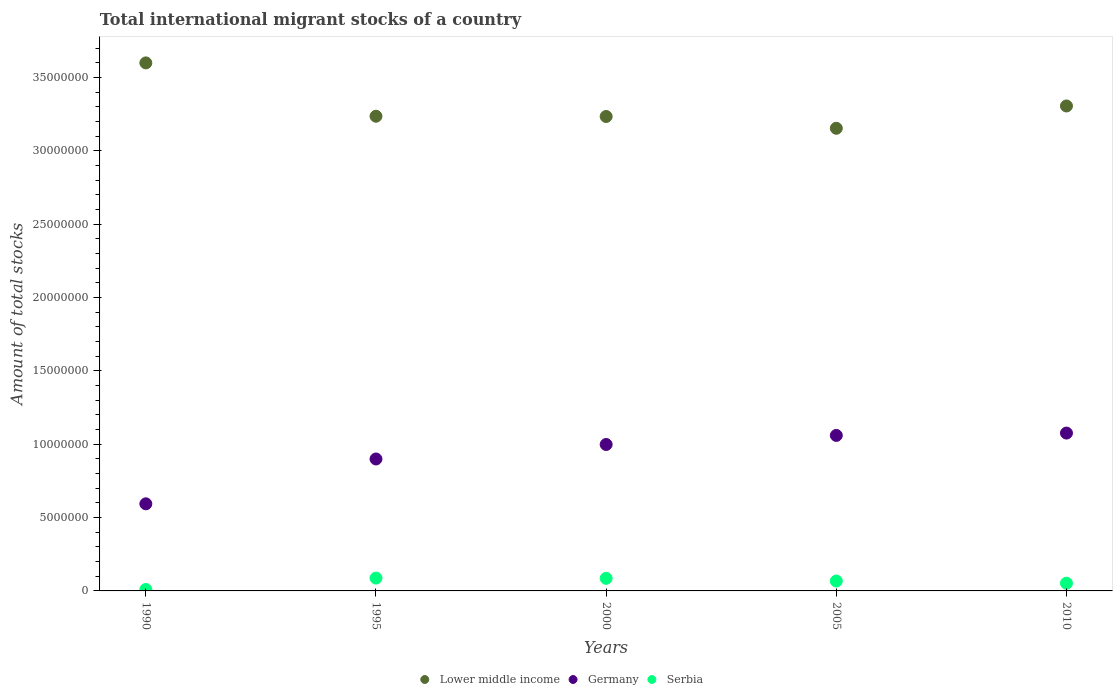Is the number of dotlines equal to the number of legend labels?
Give a very brief answer. Yes. What is the amount of total stocks in in Serbia in 2010?
Your response must be concise. 5.25e+05. Across all years, what is the maximum amount of total stocks in in Germany?
Keep it short and to the point. 1.08e+07. Across all years, what is the minimum amount of total stocks in in Lower middle income?
Offer a very short reply. 3.15e+07. In which year was the amount of total stocks in in Germany minimum?
Provide a succinct answer. 1990. What is the total amount of total stocks in in Germany in the graph?
Make the answer very short. 4.63e+07. What is the difference between the amount of total stocks in in Germany in 1990 and that in 2010?
Offer a very short reply. -4.82e+06. What is the difference between the amount of total stocks in in Germany in 1995 and the amount of total stocks in in Serbia in 2010?
Provide a succinct answer. 8.47e+06. What is the average amount of total stocks in in Lower middle income per year?
Offer a terse response. 3.31e+07. In the year 2000, what is the difference between the amount of total stocks in in Lower middle income and amount of total stocks in in Germany?
Provide a succinct answer. 2.24e+07. What is the ratio of the amount of total stocks in in Lower middle income in 2000 to that in 2005?
Provide a short and direct response. 1.03. Is the amount of total stocks in in Serbia in 1995 less than that in 2010?
Ensure brevity in your answer.  No. What is the difference between the highest and the second highest amount of total stocks in in Serbia?
Your answer should be very brief. 1.70e+04. What is the difference between the highest and the lowest amount of total stocks in in Lower middle income?
Ensure brevity in your answer.  4.46e+06. Is the sum of the amount of total stocks in in Germany in 2000 and 2010 greater than the maximum amount of total stocks in in Serbia across all years?
Provide a succinct answer. Yes. How many dotlines are there?
Your answer should be very brief. 3. How many years are there in the graph?
Your answer should be very brief. 5. What is the difference between two consecutive major ticks on the Y-axis?
Ensure brevity in your answer.  5.00e+06. Are the values on the major ticks of Y-axis written in scientific E-notation?
Offer a terse response. No. Does the graph contain any zero values?
Your answer should be compact. No. Does the graph contain grids?
Make the answer very short. No. How are the legend labels stacked?
Keep it short and to the point. Horizontal. What is the title of the graph?
Offer a terse response. Total international migrant stocks of a country. Does "Peru" appear as one of the legend labels in the graph?
Make the answer very short. No. What is the label or title of the Y-axis?
Provide a short and direct response. Amount of total stocks. What is the Amount of total stocks of Lower middle income in 1990?
Keep it short and to the point. 3.60e+07. What is the Amount of total stocks in Germany in 1990?
Ensure brevity in your answer.  5.94e+06. What is the Amount of total stocks in Serbia in 1990?
Ensure brevity in your answer.  9.93e+04. What is the Amount of total stocks of Lower middle income in 1995?
Provide a succinct answer. 3.24e+07. What is the Amount of total stocks of Germany in 1995?
Offer a very short reply. 8.99e+06. What is the Amount of total stocks of Serbia in 1995?
Offer a terse response. 8.74e+05. What is the Amount of total stocks in Lower middle income in 2000?
Your response must be concise. 3.23e+07. What is the Amount of total stocks of Germany in 2000?
Provide a short and direct response. 9.98e+06. What is the Amount of total stocks in Serbia in 2000?
Provide a short and direct response. 8.57e+05. What is the Amount of total stocks of Lower middle income in 2005?
Ensure brevity in your answer.  3.15e+07. What is the Amount of total stocks of Germany in 2005?
Provide a succinct answer. 1.06e+07. What is the Amount of total stocks in Serbia in 2005?
Give a very brief answer. 6.75e+05. What is the Amount of total stocks in Lower middle income in 2010?
Provide a short and direct response. 3.31e+07. What is the Amount of total stocks of Germany in 2010?
Provide a succinct answer. 1.08e+07. What is the Amount of total stocks in Serbia in 2010?
Give a very brief answer. 5.25e+05. Across all years, what is the maximum Amount of total stocks of Lower middle income?
Your answer should be very brief. 3.60e+07. Across all years, what is the maximum Amount of total stocks of Germany?
Offer a terse response. 1.08e+07. Across all years, what is the maximum Amount of total stocks in Serbia?
Provide a succinct answer. 8.74e+05. Across all years, what is the minimum Amount of total stocks in Lower middle income?
Your answer should be compact. 3.15e+07. Across all years, what is the minimum Amount of total stocks in Germany?
Provide a succinct answer. 5.94e+06. Across all years, what is the minimum Amount of total stocks in Serbia?
Your answer should be very brief. 9.93e+04. What is the total Amount of total stocks of Lower middle income in the graph?
Make the answer very short. 1.65e+08. What is the total Amount of total stocks in Germany in the graph?
Keep it short and to the point. 4.63e+07. What is the total Amount of total stocks of Serbia in the graph?
Make the answer very short. 3.03e+06. What is the difference between the Amount of total stocks of Lower middle income in 1990 and that in 1995?
Provide a succinct answer. 3.63e+06. What is the difference between the Amount of total stocks in Germany in 1990 and that in 1995?
Make the answer very short. -3.06e+06. What is the difference between the Amount of total stocks in Serbia in 1990 and that in 1995?
Ensure brevity in your answer.  -7.75e+05. What is the difference between the Amount of total stocks of Lower middle income in 1990 and that in 2000?
Give a very brief answer. 3.65e+06. What is the difference between the Amount of total stocks in Germany in 1990 and that in 2000?
Provide a short and direct response. -4.04e+06. What is the difference between the Amount of total stocks in Serbia in 1990 and that in 2000?
Make the answer very short. -7.57e+05. What is the difference between the Amount of total stocks in Lower middle income in 1990 and that in 2005?
Provide a succinct answer. 4.46e+06. What is the difference between the Amount of total stocks in Germany in 1990 and that in 2005?
Your answer should be very brief. -4.66e+06. What is the difference between the Amount of total stocks in Serbia in 1990 and that in 2005?
Provide a succinct answer. -5.75e+05. What is the difference between the Amount of total stocks in Lower middle income in 1990 and that in 2010?
Your answer should be compact. 2.94e+06. What is the difference between the Amount of total stocks in Germany in 1990 and that in 2010?
Offer a very short reply. -4.82e+06. What is the difference between the Amount of total stocks in Serbia in 1990 and that in 2010?
Your response must be concise. -4.26e+05. What is the difference between the Amount of total stocks of Lower middle income in 1995 and that in 2000?
Offer a terse response. 1.76e+04. What is the difference between the Amount of total stocks of Germany in 1995 and that in 2000?
Provide a short and direct response. -9.89e+05. What is the difference between the Amount of total stocks in Serbia in 1995 and that in 2000?
Your answer should be very brief. 1.70e+04. What is the difference between the Amount of total stocks of Lower middle income in 1995 and that in 2005?
Your answer should be very brief. 8.21e+05. What is the difference between the Amount of total stocks of Germany in 1995 and that in 2005?
Provide a short and direct response. -1.61e+06. What is the difference between the Amount of total stocks in Serbia in 1995 and that in 2005?
Your answer should be very brief. 1.99e+05. What is the difference between the Amount of total stocks in Lower middle income in 1995 and that in 2010?
Your answer should be very brief. -6.99e+05. What is the difference between the Amount of total stocks of Germany in 1995 and that in 2010?
Keep it short and to the point. -1.77e+06. What is the difference between the Amount of total stocks of Serbia in 1995 and that in 2010?
Provide a short and direct response. 3.48e+05. What is the difference between the Amount of total stocks in Lower middle income in 2000 and that in 2005?
Give a very brief answer. 8.03e+05. What is the difference between the Amount of total stocks in Germany in 2000 and that in 2005?
Keep it short and to the point. -6.17e+05. What is the difference between the Amount of total stocks of Serbia in 2000 and that in 2005?
Provide a succinct answer. 1.82e+05. What is the difference between the Amount of total stocks of Lower middle income in 2000 and that in 2010?
Offer a terse response. -7.16e+05. What is the difference between the Amount of total stocks in Germany in 2000 and that in 2010?
Offer a terse response. -7.77e+05. What is the difference between the Amount of total stocks of Serbia in 2000 and that in 2010?
Make the answer very short. 3.31e+05. What is the difference between the Amount of total stocks of Lower middle income in 2005 and that in 2010?
Provide a succinct answer. -1.52e+06. What is the difference between the Amount of total stocks in Germany in 2005 and that in 2010?
Ensure brevity in your answer.  -1.60e+05. What is the difference between the Amount of total stocks of Serbia in 2005 and that in 2010?
Make the answer very short. 1.49e+05. What is the difference between the Amount of total stocks in Lower middle income in 1990 and the Amount of total stocks in Germany in 1995?
Keep it short and to the point. 2.70e+07. What is the difference between the Amount of total stocks in Lower middle income in 1990 and the Amount of total stocks in Serbia in 1995?
Keep it short and to the point. 3.51e+07. What is the difference between the Amount of total stocks of Germany in 1990 and the Amount of total stocks of Serbia in 1995?
Make the answer very short. 5.06e+06. What is the difference between the Amount of total stocks in Lower middle income in 1990 and the Amount of total stocks in Germany in 2000?
Offer a very short reply. 2.60e+07. What is the difference between the Amount of total stocks in Lower middle income in 1990 and the Amount of total stocks in Serbia in 2000?
Your response must be concise. 3.51e+07. What is the difference between the Amount of total stocks in Germany in 1990 and the Amount of total stocks in Serbia in 2000?
Your answer should be very brief. 5.08e+06. What is the difference between the Amount of total stocks in Lower middle income in 1990 and the Amount of total stocks in Germany in 2005?
Offer a terse response. 2.54e+07. What is the difference between the Amount of total stocks of Lower middle income in 1990 and the Amount of total stocks of Serbia in 2005?
Your answer should be compact. 3.53e+07. What is the difference between the Amount of total stocks in Germany in 1990 and the Amount of total stocks in Serbia in 2005?
Make the answer very short. 5.26e+06. What is the difference between the Amount of total stocks of Lower middle income in 1990 and the Amount of total stocks of Germany in 2010?
Make the answer very short. 2.52e+07. What is the difference between the Amount of total stocks in Lower middle income in 1990 and the Amount of total stocks in Serbia in 2010?
Your response must be concise. 3.55e+07. What is the difference between the Amount of total stocks in Germany in 1990 and the Amount of total stocks in Serbia in 2010?
Provide a short and direct response. 5.41e+06. What is the difference between the Amount of total stocks of Lower middle income in 1995 and the Amount of total stocks of Germany in 2000?
Offer a very short reply. 2.24e+07. What is the difference between the Amount of total stocks of Lower middle income in 1995 and the Amount of total stocks of Serbia in 2000?
Give a very brief answer. 3.15e+07. What is the difference between the Amount of total stocks in Germany in 1995 and the Amount of total stocks in Serbia in 2000?
Provide a short and direct response. 8.14e+06. What is the difference between the Amount of total stocks of Lower middle income in 1995 and the Amount of total stocks of Germany in 2005?
Your answer should be compact. 2.18e+07. What is the difference between the Amount of total stocks of Lower middle income in 1995 and the Amount of total stocks of Serbia in 2005?
Your answer should be compact. 3.17e+07. What is the difference between the Amount of total stocks of Germany in 1995 and the Amount of total stocks of Serbia in 2005?
Your answer should be very brief. 8.32e+06. What is the difference between the Amount of total stocks in Lower middle income in 1995 and the Amount of total stocks in Germany in 2010?
Your answer should be very brief. 2.16e+07. What is the difference between the Amount of total stocks of Lower middle income in 1995 and the Amount of total stocks of Serbia in 2010?
Give a very brief answer. 3.18e+07. What is the difference between the Amount of total stocks in Germany in 1995 and the Amount of total stocks in Serbia in 2010?
Give a very brief answer. 8.47e+06. What is the difference between the Amount of total stocks in Lower middle income in 2000 and the Amount of total stocks in Germany in 2005?
Ensure brevity in your answer.  2.17e+07. What is the difference between the Amount of total stocks in Lower middle income in 2000 and the Amount of total stocks in Serbia in 2005?
Your answer should be compact. 3.17e+07. What is the difference between the Amount of total stocks of Germany in 2000 and the Amount of total stocks of Serbia in 2005?
Offer a terse response. 9.31e+06. What is the difference between the Amount of total stocks of Lower middle income in 2000 and the Amount of total stocks of Germany in 2010?
Make the answer very short. 2.16e+07. What is the difference between the Amount of total stocks in Lower middle income in 2000 and the Amount of total stocks in Serbia in 2010?
Ensure brevity in your answer.  3.18e+07. What is the difference between the Amount of total stocks of Germany in 2000 and the Amount of total stocks of Serbia in 2010?
Your answer should be very brief. 9.46e+06. What is the difference between the Amount of total stocks in Lower middle income in 2005 and the Amount of total stocks in Germany in 2010?
Keep it short and to the point. 2.08e+07. What is the difference between the Amount of total stocks of Lower middle income in 2005 and the Amount of total stocks of Serbia in 2010?
Your response must be concise. 3.10e+07. What is the difference between the Amount of total stocks in Germany in 2005 and the Amount of total stocks in Serbia in 2010?
Ensure brevity in your answer.  1.01e+07. What is the average Amount of total stocks of Lower middle income per year?
Offer a very short reply. 3.31e+07. What is the average Amount of total stocks in Germany per year?
Provide a short and direct response. 9.25e+06. What is the average Amount of total stocks in Serbia per year?
Offer a terse response. 6.06e+05. In the year 1990, what is the difference between the Amount of total stocks of Lower middle income and Amount of total stocks of Germany?
Give a very brief answer. 3.01e+07. In the year 1990, what is the difference between the Amount of total stocks of Lower middle income and Amount of total stocks of Serbia?
Give a very brief answer. 3.59e+07. In the year 1990, what is the difference between the Amount of total stocks of Germany and Amount of total stocks of Serbia?
Provide a short and direct response. 5.84e+06. In the year 1995, what is the difference between the Amount of total stocks in Lower middle income and Amount of total stocks in Germany?
Provide a short and direct response. 2.34e+07. In the year 1995, what is the difference between the Amount of total stocks of Lower middle income and Amount of total stocks of Serbia?
Keep it short and to the point. 3.15e+07. In the year 1995, what is the difference between the Amount of total stocks of Germany and Amount of total stocks of Serbia?
Your response must be concise. 8.12e+06. In the year 2000, what is the difference between the Amount of total stocks in Lower middle income and Amount of total stocks in Germany?
Give a very brief answer. 2.24e+07. In the year 2000, what is the difference between the Amount of total stocks in Lower middle income and Amount of total stocks in Serbia?
Provide a short and direct response. 3.15e+07. In the year 2000, what is the difference between the Amount of total stocks of Germany and Amount of total stocks of Serbia?
Provide a succinct answer. 9.12e+06. In the year 2005, what is the difference between the Amount of total stocks of Lower middle income and Amount of total stocks of Germany?
Ensure brevity in your answer.  2.09e+07. In the year 2005, what is the difference between the Amount of total stocks in Lower middle income and Amount of total stocks in Serbia?
Provide a succinct answer. 3.09e+07. In the year 2005, what is the difference between the Amount of total stocks in Germany and Amount of total stocks in Serbia?
Offer a terse response. 9.92e+06. In the year 2010, what is the difference between the Amount of total stocks in Lower middle income and Amount of total stocks in Germany?
Your answer should be compact. 2.23e+07. In the year 2010, what is the difference between the Amount of total stocks of Lower middle income and Amount of total stocks of Serbia?
Your response must be concise. 3.25e+07. In the year 2010, what is the difference between the Amount of total stocks in Germany and Amount of total stocks in Serbia?
Give a very brief answer. 1.02e+07. What is the ratio of the Amount of total stocks in Lower middle income in 1990 to that in 1995?
Give a very brief answer. 1.11. What is the ratio of the Amount of total stocks in Germany in 1990 to that in 1995?
Provide a short and direct response. 0.66. What is the ratio of the Amount of total stocks in Serbia in 1990 to that in 1995?
Provide a short and direct response. 0.11. What is the ratio of the Amount of total stocks of Lower middle income in 1990 to that in 2000?
Ensure brevity in your answer.  1.11. What is the ratio of the Amount of total stocks in Germany in 1990 to that in 2000?
Make the answer very short. 0.59. What is the ratio of the Amount of total stocks of Serbia in 1990 to that in 2000?
Your response must be concise. 0.12. What is the ratio of the Amount of total stocks of Lower middle income in 1990 to that in 2005?
Your response must be concise. 1.14. What is the ratio of the Amount of total stocks in Germany in 1990 to that in 2005?
Your answer should be very brief. 0.56. What is the ratio of the Amount of total stocks in Serbia in 1990 to that in 2005?
Keep it short and to the point. 0.15. What is the ratio of the Amount of total stocks of Lower middle income in 1990 to that in 2010?
Your answer should be very brief. 1.09. What is the ratio of the Amount of total stocks of Germany in 1990 to that in 2010?
Keep it short and to the point. 0.55. What is the ratio of the Amount of total stocks in Serbia in 1990 to that in 2010?
Your response must be concise. 0.19. What is the ratio of the Amount of total stocks in Germany in 1995 to that in 2000?
Your answer should be compact. 0.9. What is the ratio of the Amount of total stocks of Serbia in 1995 to that in 2000?
Provide a succinct answer. 1.02. What is the ratio of the Amount of total stocks in Germany in 1995 to that in 2005?
Keep it short and to the point. 0.85. What is the ratio of the Amount of total stocks of Serbia in 1995 to that in 2005?
Your response must be concise. 1.3. What is the ratio of the Amount of total stocks of Lower middle income in 1995 to that in 2010?
Ensure brevity in your answer.  0.98. What is the ratio of the Amount of total stocks of Germany in 1995 to that in 2010?
Ensure brevity in your answer.  0.84. What is the ratio of the Amount of total stocks of Serbia in 1995 to that in 2010?
Provide a succinct answer. 1.66. What is the ratio of the Amount of total stocks in Lower middle income in 2000 to that in 2005?
Keep it short and to the point. 1.03. What is the ratio of the Amount of total stocks of Germany in 2000 to that in 2005?
Make the answer very short. 0.94. What is the ratio of the Amount of total stocks of Serbia in 2000 to that in 2005?
Keep it short and to the point. 1.27. What is the ratio of the Amount of total stocks of Lower middle income in 2000 to that in 2010?
Your response must be concise. 0.98. What is the ratio of the Amount of total stocks of Germany in 2000 to that in 2010?
Ensure brevity in your answer.  0.93. What is the ratio of the Amount of total stocks in Serbia in 2000 to that in 2010?
Give a very brief answer. 1.63. What is the ratio of the Amount of total stocks of Lower middle income in 2005 to that in 2010?
Keep it short and to the point. 0.95. What is the ratio of the Amount of total stocks in Germany in 2005 to that in 2010?
Give a very brief answer. 0.99. What is the ratio of the Amount of total stocks of Serbia in 2005 to that in 2010?
Offer a very short reply. 1.28. What is the difference between the highest and the second highest Amount of total stocks in Lower middle income?
Offer a terse response. 2.94e+06. What is the difference between the highest and the second highest Amount of total stocks of Germany?
Your response must be concise. 1.60e+05. What is the difference between the highest and the second highest Amount of total stocks in Serbia?
Your answer should be compact. 1.70e+04. What is the difference between the highest and the lowest Amount of total stocks of Lower middle income?
Offer a very short reply. 4.46e+06. What is the difference between the highest and the lowest Amount of total stocks in Germany?
Give a very brief answer. 4.82e+06. What is the difference between the highest and the lowest Amount of total stocks in Serbia?
Provide a short and direct response. 7.75e+05. 